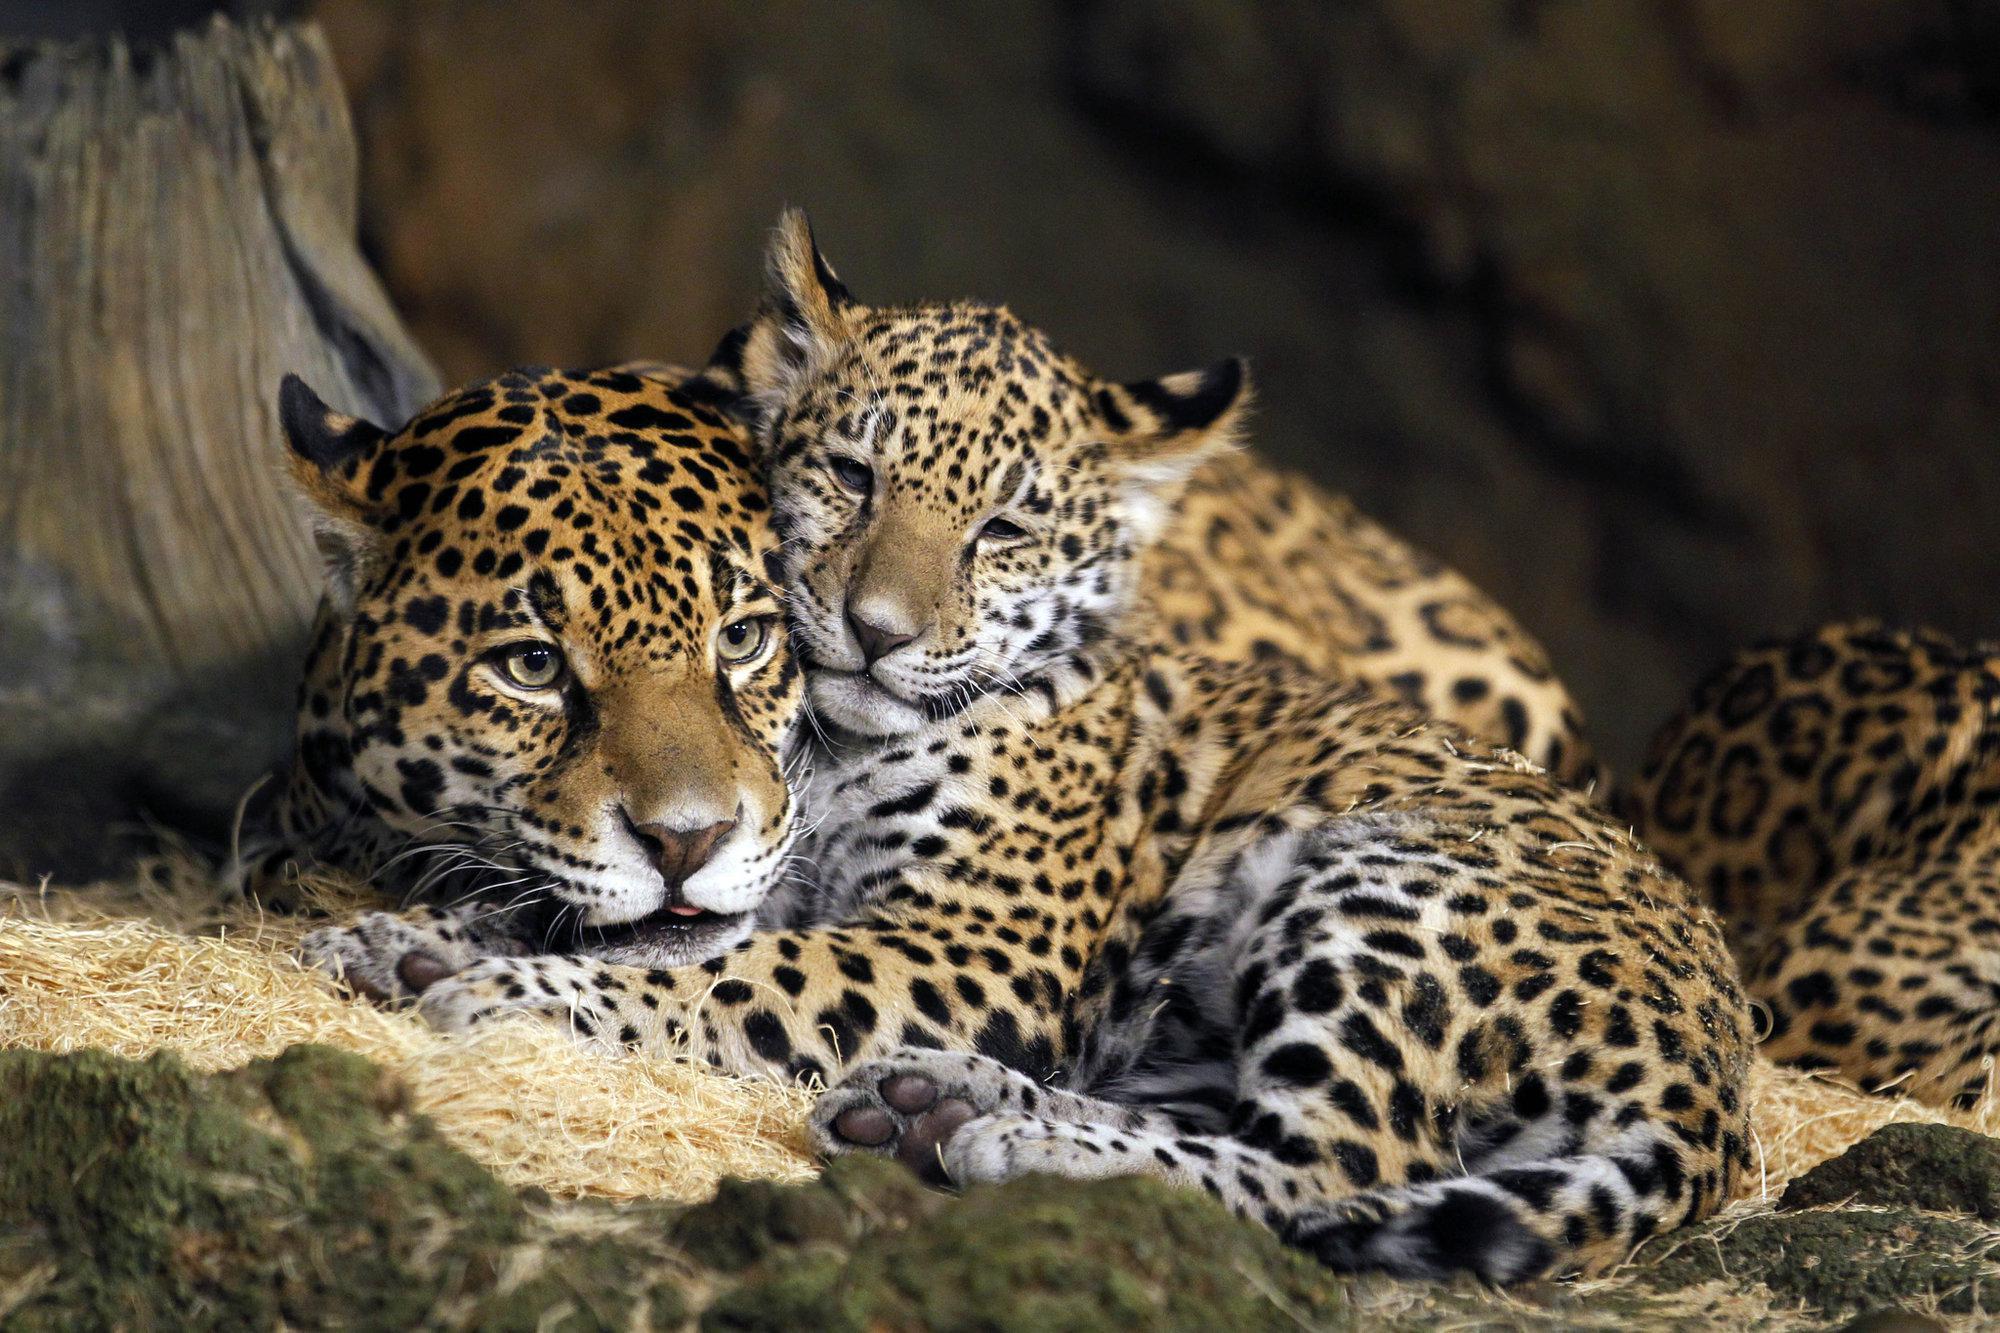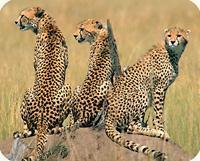The first image is the image on the left, the second image is the image on the right. Analyze the images presented: Is the assertion "There are three adult cheetahs in one image and three cheetah cubs in the other image." valid? Answer yes or no. No. The first image is the image on the left, the second image is the image on the right. Assess this claim about the two images: "At least two animals are laying down.". Correct or not? Answer yes or no. Yes. 